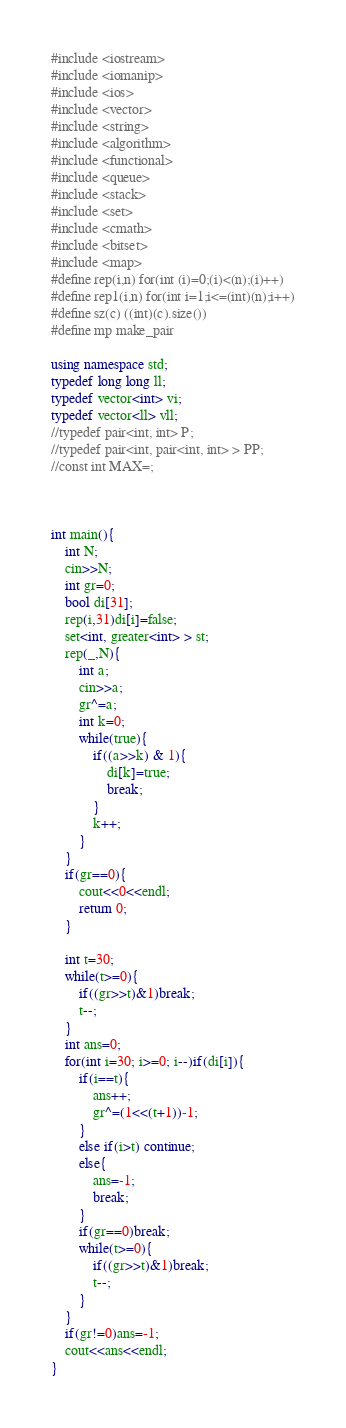<code> <loc_0><loc_0><loc_500><loc_500><_C++_>#include <iostream>
#include <iomanip>
#include <ios> 
#include <vector>
#include <string>
#include <algorithm>
#include <functional>
#include <queue>
#include <stack>
#include <set>
#include <cmath>
#include <bitset>
#include <map>
#define rep(i,n) for(int (i)=0;(i)<(n);(i)++)
#define rep1(i,n) for(int i=1;i<=(int)(n);i++)
#define sz(c) ((int)(c).size())
#define mp make_pair

using namespace std;
typedef long long ll;
typedef vector<int> vi;
typedef vector<ll> vll;
//typedef pair<int, int> P;
//typedef pair<int, pair<int, int> > PP;
//const int MAX=;



int main(){
	int N;
	cin>>N;
	int gr=0;
	bool di[31];
	rep(i,31)di[i]=false;
	set<int, greater<int> > st;
	rep(_,N){
		int a;
      	cin>>a;
		gr^=a;
		int k=0;
		while(true){
			if((a>>k) & 1){
				di[k]=true;
				break;
			}
			k++;
		}
	}
	if(gr==0){
		cout<<0<<endl;
		return 0;
	}
	
	int t=30;
	while(t>=0){
		if((gr>>t)&1)break;
		t--;
	}
	int ans=0;
	for(int i=30; i>=0; i--)if(di[i]){
		if(i==t){
			ans++;
			gr^=(1<<(t+1))-1;
		}
		else if(i>t) continue;
		else{
			ans=-1;
			break;
		}
		if(gr==0)break;
		while(t>=0){
			if((gr>>t)&1)break;
			t--;
		}
	}
	if(gr!=0)ans=-1;
	cout<<ans<<endl;
}</code> 